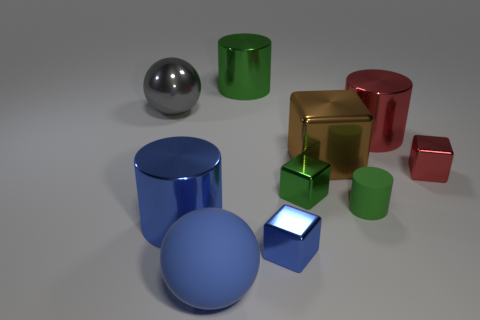Subtract 1 cylinders. How many cylinders are left? 3 Subtract all blocks. How many objects are left? 6 Add 2 large brown metallic things. How many large brown metallic things exist? 3 Subtract 0 yellow cylinders. How many objects are left? 10 Subtract all gray rubber cubes. Subtract all small green metal objects. How many objects are left? 9 Add 8 rubber cylinders. How many rubber cylinders are left? 9 